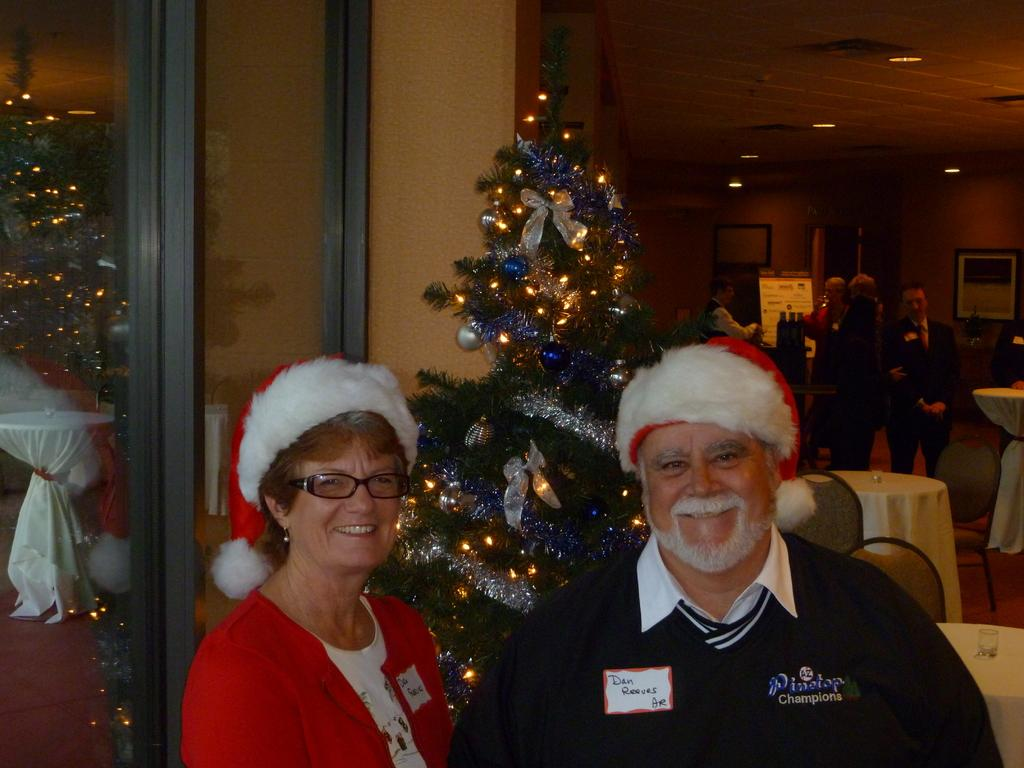<image>
Summarize the visual content of the image. An older man and woman wearing Santa hats stand in front of a Christmas tree, the man is wearing a nametag that says Dan Reeves. 